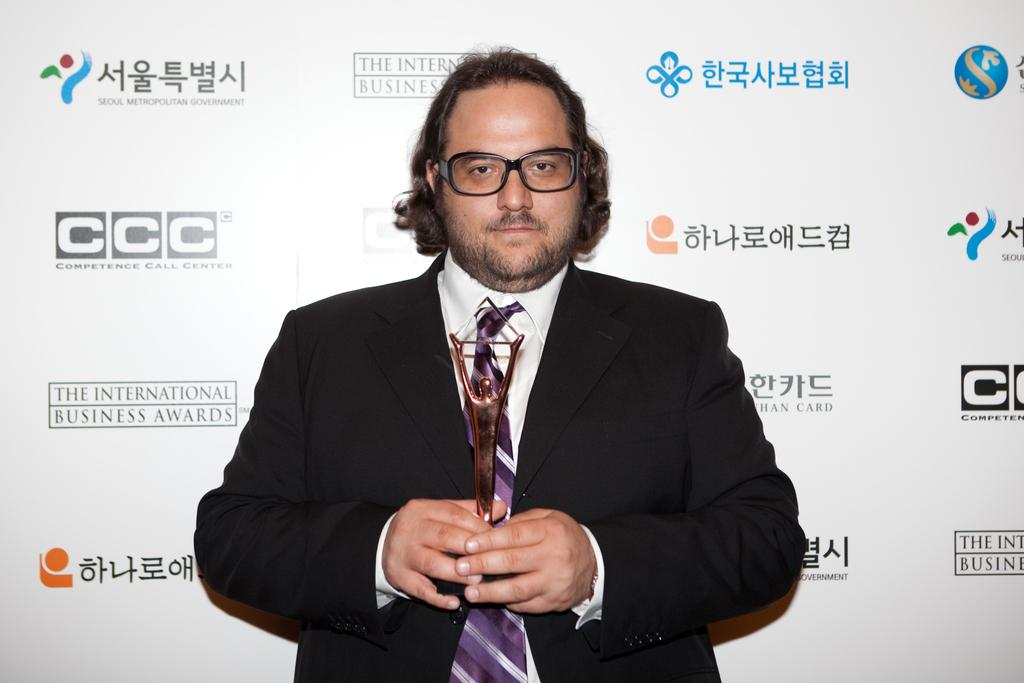What is the appearance of the person in the image? The person in the image is wearing a black suit. What is the person doing in the image? The person is standing and holding an award in his hand. What can be seen in the background of the image? There is a banner in the background of the image. What scientific experiment is being conducted in the image? There is no scientific experiment being conducted in the image; it features a person holding an award. What shape is the award in the image? The shape of the award cannot be determined from the image. 